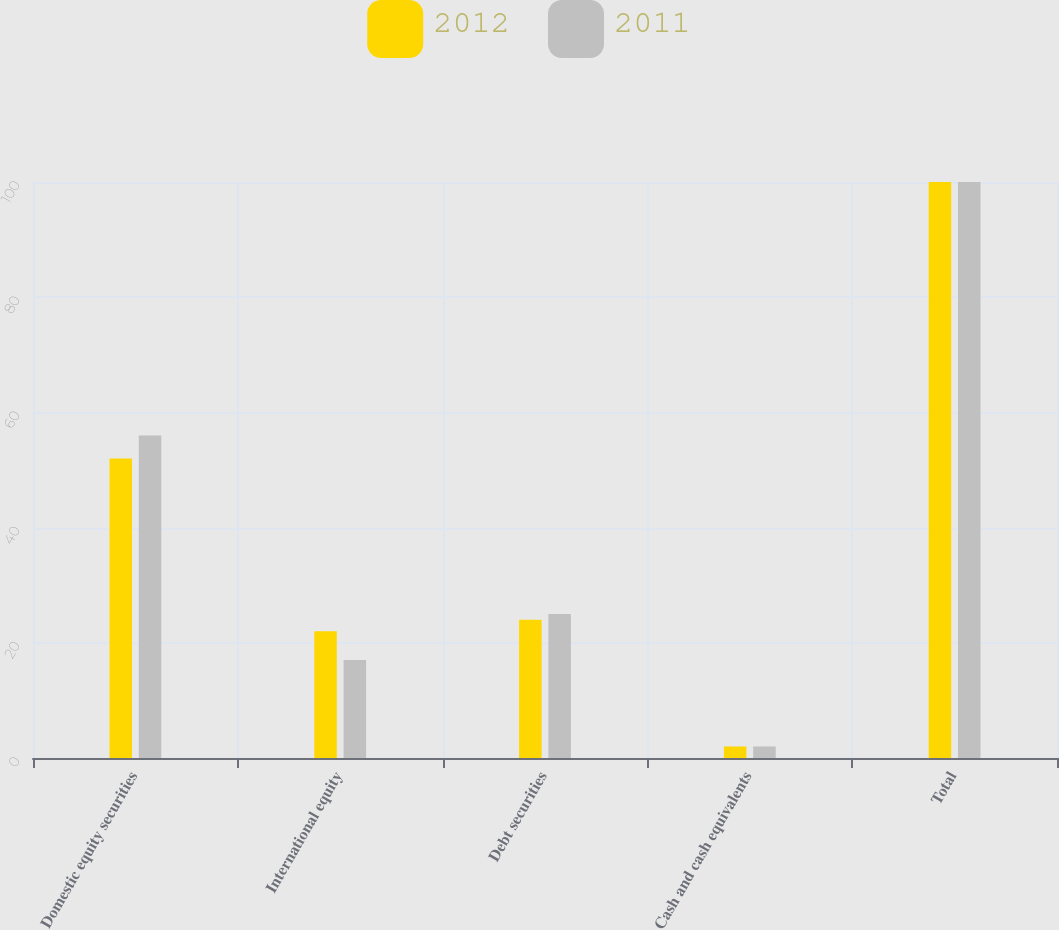<chart> <loc_0><loc_0><loc_500><loc_500><stacked_bar_chart><ecel><fcel>Domestic equity securities<fcel>International equity<fcel>Debt securities<fcel>Cash and cash equivalents<fcel>Total<nl><fcel>2012<fcel>52<fcel>22<fcel>24<fcel>2<fcel>100<nl><fcel>2011<fcel>56<fcel>17<fcel>25<fcel>2<fcel>100<nl></chart> 